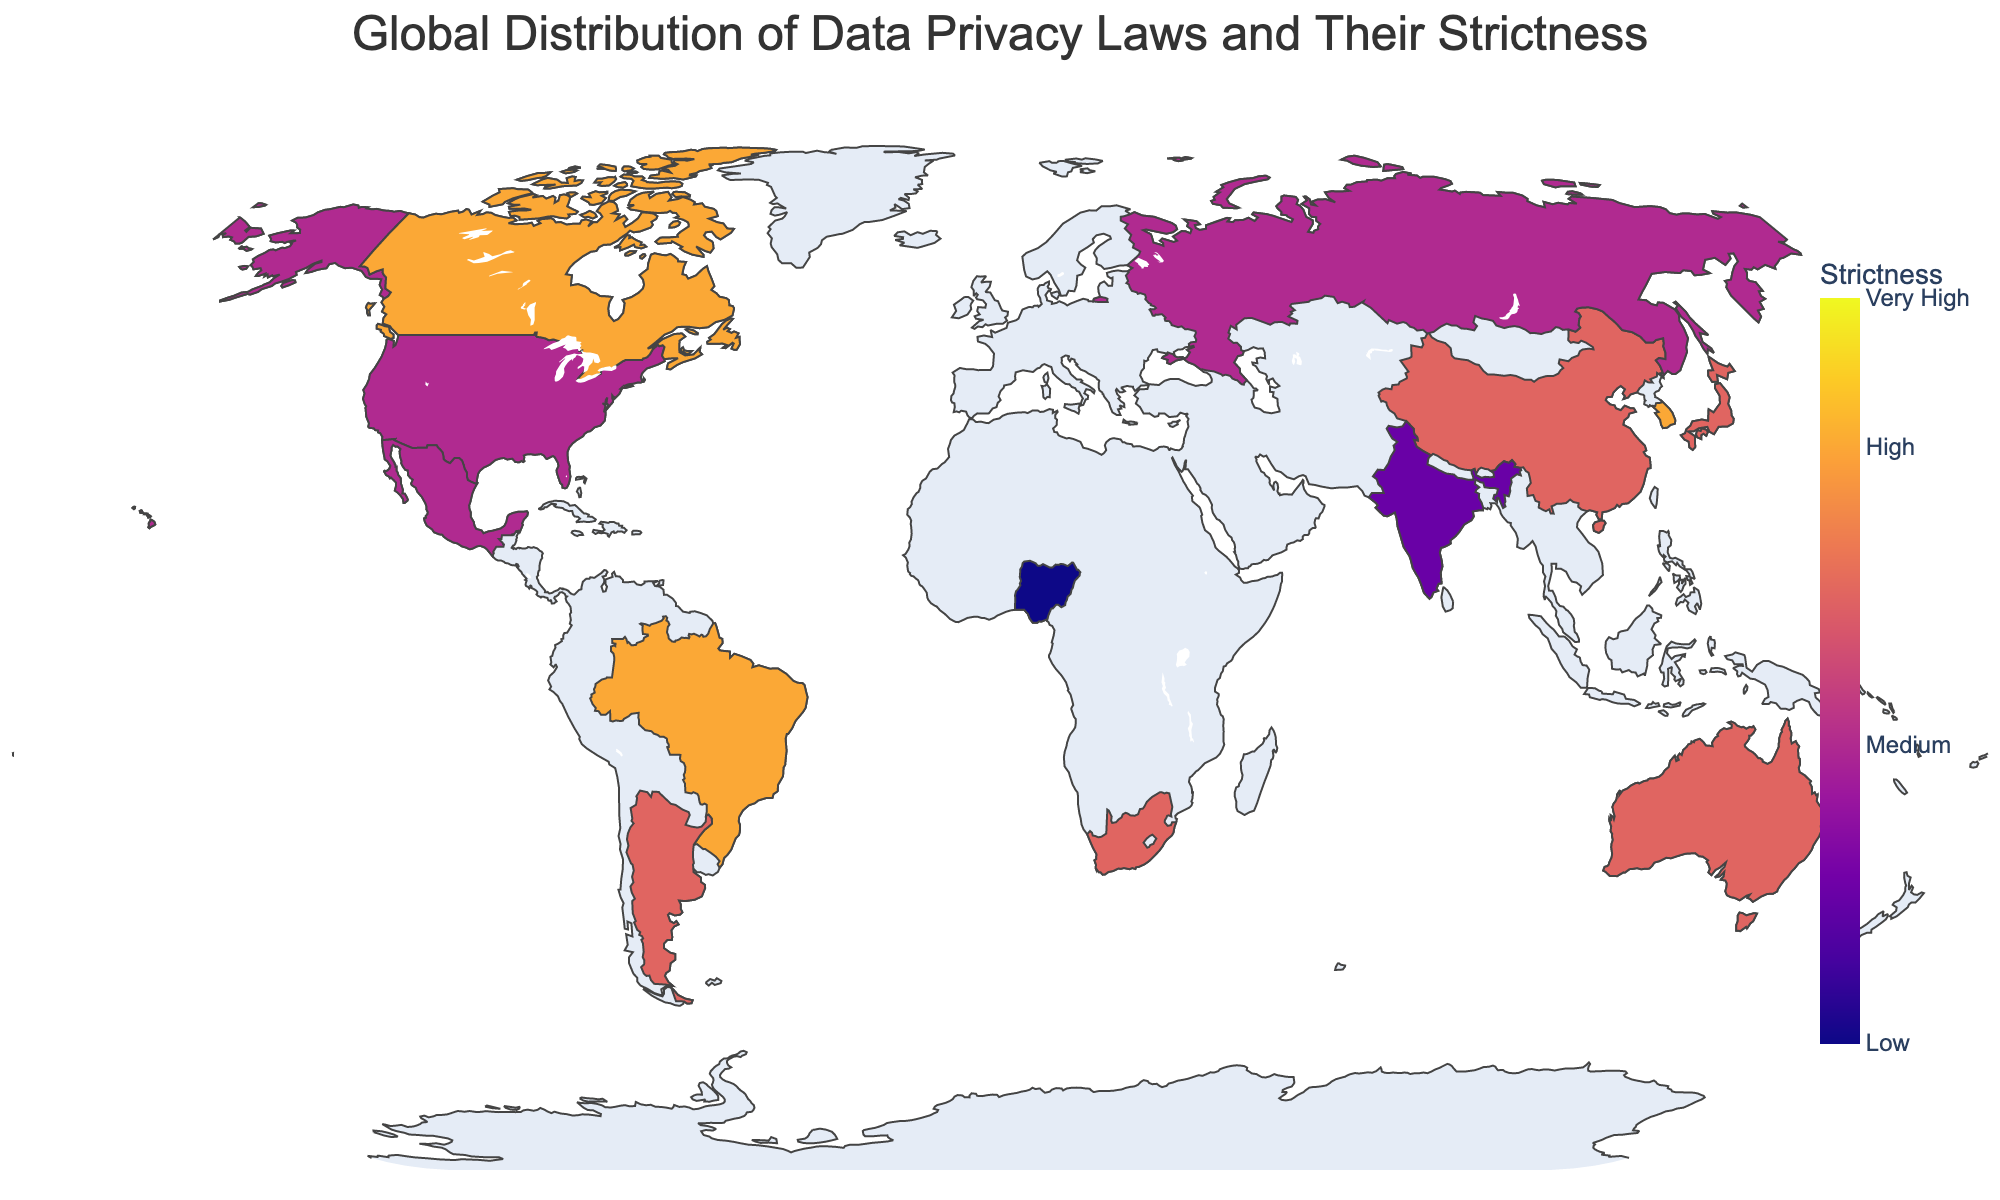What is the title of the plot? The title is usually positioned at the top of the plot, and it provides a succinct summary of what the plot is about. In this case, it says: "Global Distribution of Data Privacy Laws and Their Strictness".
Answer: "Global Distribution of Data Privacy Laws and Their Strictness" What color scale is used to represent the strictness of data privacy laws? The color scale defines the visual representation of data values in the plot. Here, the color scale used is Plasma, which ranges from lighter colors for lower values to darker colors for higher values.
Answer: Plasma Which region has the highest strictness level for data privacy laws? By observing the colors on the plot, we need to find the darkest shades as they represent higher strictness values. The European Union, which is painted in the darkest color, has a strictness level of 9.
Answer: European Union What is the data privacy legislation in Brazil, and how strict is it? Hovering over Brazil on the map, it shows the "General Data Protection Law (LGPD)" and the strictness value of 8.
Answer: General Data Protection Law (LGPD), 8 How many countries have a strictness level of 7? The plot shows different colors representing strictness values. Counting the number of countries with the color corresponding to a strictness level of 7 yields six countries: China, Japan, Australia, Singapore, South Africa, and Argentina.
Answer: 6 Which country has the least strict data privacy law, and what is the legislation called? By identifying the country with the lightest color, we see that Nigeria has the least strict data privacy law with a strictness level of 4, called the Nigeria Data Protection Regulation (NDPR).
Answer: Nigeria, Nigeria Data Protection Regulation (NDPR) What is the strictness level difference between the United States and Canada? The strictness level of the United States is 6, and Canada's is 8, so the difference is 8 - 6 = 2.
Answer: 2 Which countries have data privacy laws that score 8 on strictness? By looking for the countries colored to represent a strictness level of 8, we identify Brazil, Canada, and South Korea.
Answer: Brazil, Canada, South Korea Is there any country on the map with a pending data privacy bill, and what is its strictness level? Hovering over the countries, we find that India has a pending data privacy bill, the Personal Data Protection Bill, with a strictness level of 5.
Answer: India, 5 What is the mean strictness level of data privacy laws among all countries in the plot? Add the strictness values for all countries: 6 + 9 + 7 + 7 + 8 + 5 + 7 + 8 + 6 + 8 + 7 + 6 + 7 + 7 + 4 = 96. There are 15 countries. Mean = 96 / 15 = 6.4.
Answer: 6.4 